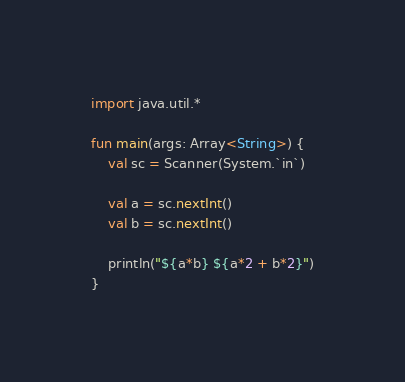Convert code to text. <code><loc_0><loc_0><loc_500><loc_500><_Kotlin_>import java.util.*

fun main(args: Array<String>) {
    val sc = Scanner(System.`in`)

    val a = sc.nextInt()
    val b = sc.nextInt()

    println("${a*b} ${a*2 + b*2}")
}
</code> 